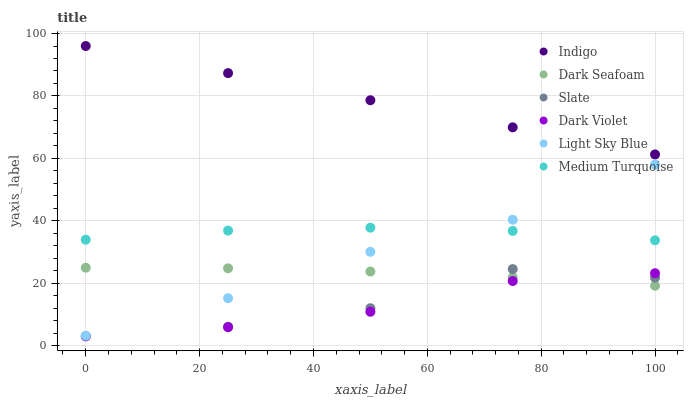Does Dark Violet have the minimum area under the curve?
Answer yes or no. Yes. Does Indigo have the maximum area under the curve?
Answer yes or no. Yes. Does Slate have the minimum area under the curve?
Answer yes or no. No. Does Slate have the maximum area under the curve?
Answer yes or no. No. Is Indigo the smoothest?
Answer yes or no. Yes. Is Slate the roughest?
Answer yes or no. Yes. Is Dark Violet the smoothest?
Answer yes or no. No. Is Dark Violet the roughest?
Answer yes or no. No. Does Slate have the lowest value?
Answer yes or no. Yes. Does Dark Seafoam have the lowest value?
Answer yes or no. No. Does Indigo have the highest value?
Answer yes or no. Yes. Does Slate have the highest value?
Answer yes or no. No. Is Dark Seafoam less than Medium Turquoise?
Answer yes or no. Yes. Is Indigo greater than Dark Seafoam?
Answer yes or no. Yes. Does Dark Seafoam intersect Dark Violet?
Answer yes or no. Yes. Is Dark Seafoam less than Dark Violet?
Answer yes or no. No. Is Dark Seafoam greater than Dark Violet?
Answer yes or no. No. Does Dark Seafoam intersect Medium Turquoise?
Answer yes or no. No. 